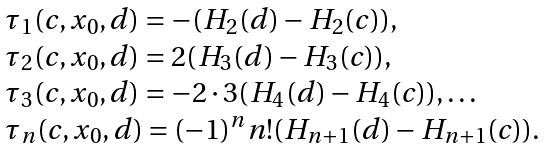Convert formula to latex. <formula><loc_0><loc_0><loc_500><loc_500>\begin{array} { l l l l } \tau _ { 1 } ( c , x _ { 0 } , d ) = - ( H _ { 2 } ( d ) - H _ { 2 } ( c ) ) , \\ \tau _ { 2 } ( c , x _ { 0 } , d ) = 2 ( H _ { 3 } ( d ) - H _ { 3 } ( c ) ) , \\ \tau _ { 3 } ( c , x _ { 0 } , d ) = - 2 \cdot 3 ( H _ { 4 } ( d ) - H _ { 4 } ( c ) ) , \dots \\ \tau _ { n } ( c , x _ { 0 } , d ) = ( - 1 ) ^ { n } n ! ( H _ { n + 1 } ( d ) - H _ { n + 1 } ( c ) ) . \end{array}</formula> 